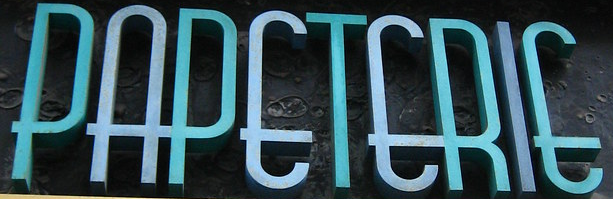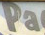Read the text content from these images in order, separated by a semicolon. PAPETERIE; Pa 